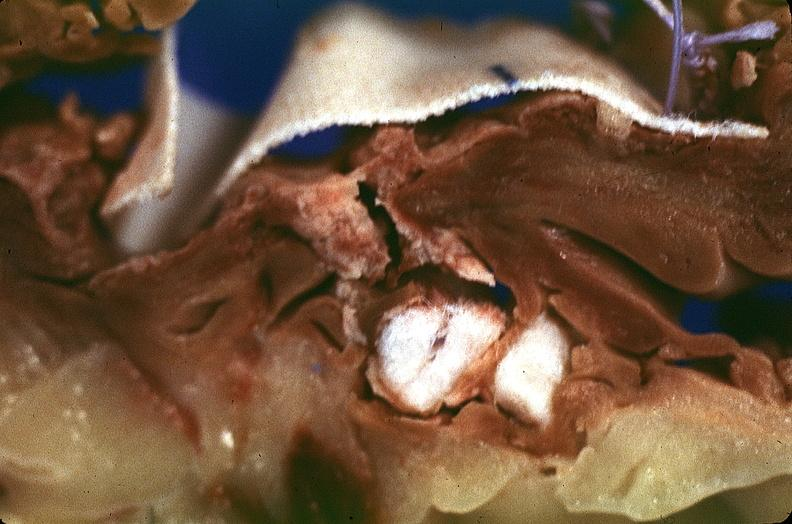s cardiovascular present?
Answer the question using a single word or phrase. Yes 